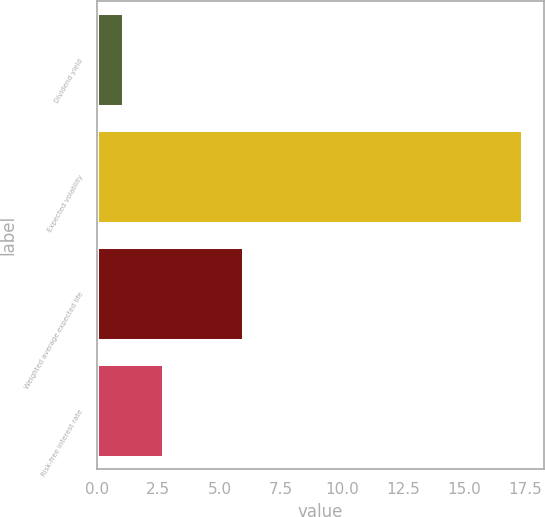Convert chart to OTSL. <chart><loc_0><loc_0><loc_500><loc_500><bar_chart><fcel>Dividend yield<fcel>Expected volatility<fcel>Weighted average expected life<fcel>Risk-free interest rate<nl><fcel>1.1<fcel>17.4<fcel>6<fcel>2.73<nl></chart> 